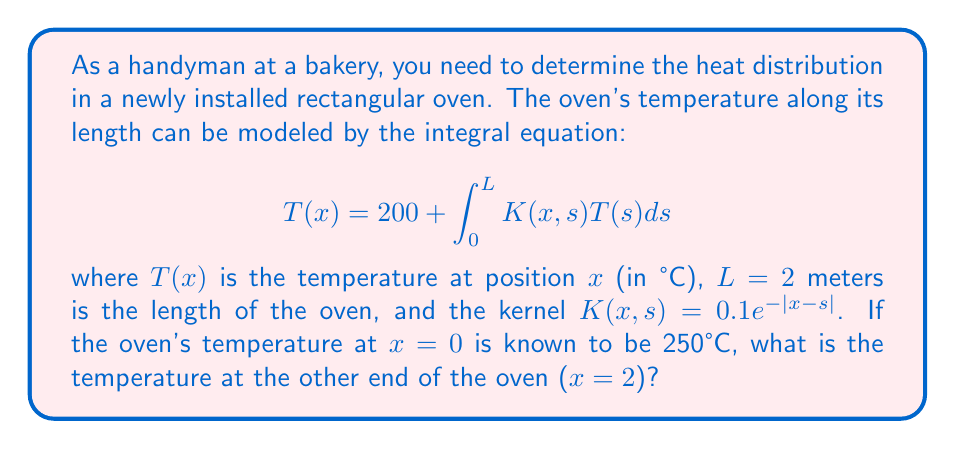Can you answer this question? To solve this problem, we'll use the given integral equation and follow these steps:

1) First, we need to set up the equation for $x=2$:

   $$T(2) = 200 + \int_0^2 0.1e^{-|2-s|}T(s)ds$$

2) We don't know $T(s)$ for all $s$, but we know $T(0) = 250$. Let's assume $T(s)$ is approximately constant and equal to $T(0)$ for simplicity:

   $$T(2) \approx 200 + 250 \int_0^2 0.1e^{-|2-s|}ds$$

3) Now we need to evaluate the integral:

   $$\int_0^2 0.1e^{-|2-s|}ds = 0.1 \left(\int_0^2 e^{-(2-s)}ds\right)$$

4) Solve the integral:

   $$0.1 \left[-e^{-(2-s)}\right]_0^2 = 0.1 \left[-e^{0} + e^{-2}\right] = 0.1(1 - e^{-2}) \approx 0.086$$

5) Substitute this result back into the equation:

   $$T(2) \approx 200 + 250 \times 0.086 = 200 + 21.5 = 221.5$$

Therefore, the temperature at the other end of the oven ($x=2$) is approximately 221.5°C.
Answer: 221.5°C 